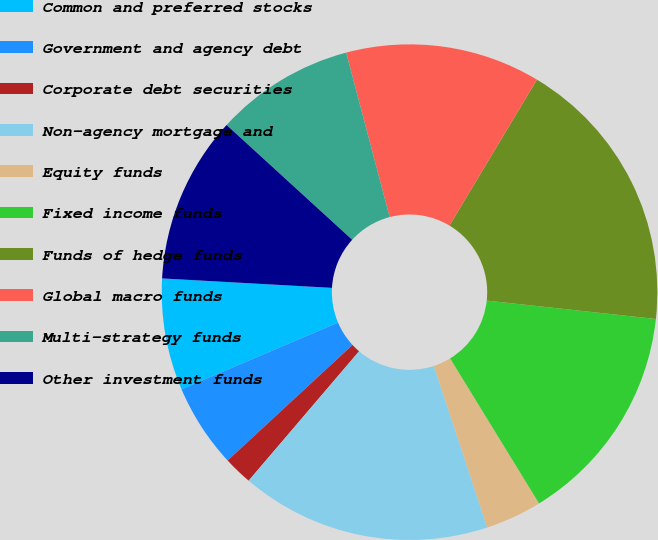<chart> <loc_0><loc_0><loc_500><loc_500><pie_chart><fcel>Common and preferred stocks<fcel>Government and agency debt<fcel>Corporate debt securities<fcel>Non-agency mortgage and<fcel>Equity funds<fcel>Fixed income funds<fcel>Funds of hedge funds<fcel>Global macro funds<fcel>Multi-strategy funds<fcel>Other investment funds<nl><fcel>7.29%<fcel>5.48%<fcel>1.87%<fcel>16.32%<fcel>3.68%<fcel>14.52%<fcel>18.13%<fcel>12.71%<fcel>9.1%<fcel>10.9%<nl></chart> 